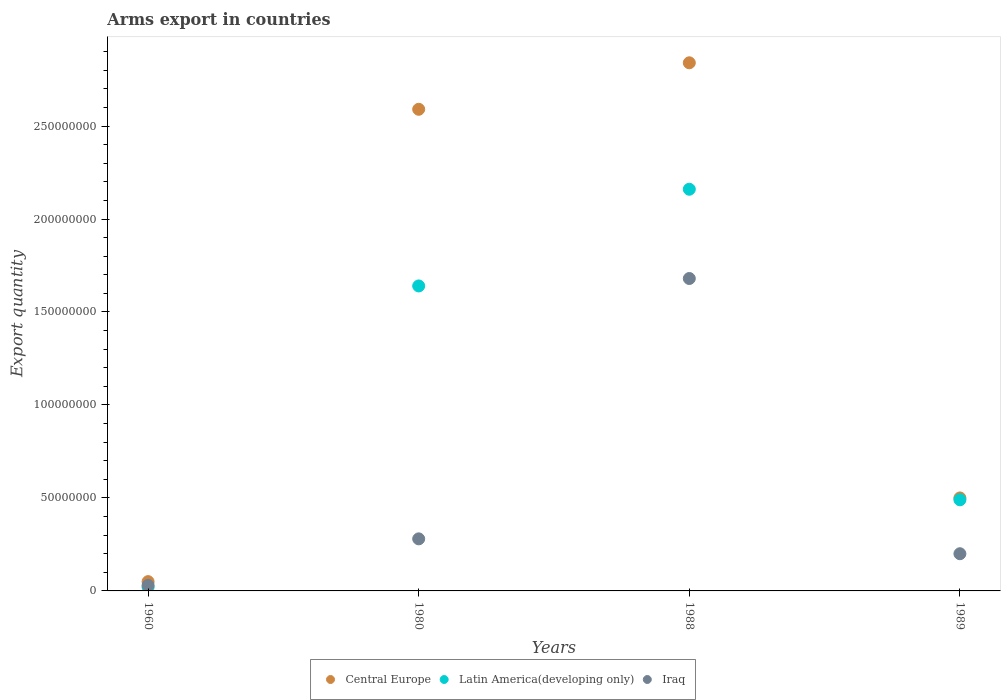Is the number of dotlines equal to the number of legend labels?
Offer a terse response. Yes. What is the total arms export in Iraq in 1989?
Offer a terse response. 2.00e+07. Across all years, what is the maximum total arms export in Central Europe?
Provide a short and direct response. 2.84e+08. In which year was the total arms export in Central Europe maximum?
Keep it short and to the point. 1988. In which year was the total arms export in Central Europe minimum?
Your response must be concise. 1960. What is the total total arms export in Central Europe in the graph?
Offer a terse response. 5.98e+08. What is the difference between the total arms export in Central Europe in 1960 and that in 1989?
Keep it short and to the point. -4.50e+07. What is the difference between the total arms export in Latin America(developing only) in 1988 and the total arms export in Central Europe in 1989?
Keep it short and to the point. 1.66e+08. What is the average total arms export in Latin America(developing only) per year?
Give a very brief answer. 1.08e+08. In the year 1960, what is the difference between the total arms export in Latin America(developing only) and total arms export in Iraq?
Provide a short and direct response. -1.00e+06. In how many years, is the total arms export in Central Europe greater than 90000000?
Make the answer very short. 2. What is the ratio of the total arms export in Central Europe in 1960 to that in 1980?
Your answer should be very brief. 0.02. What is the difference between the highest and the second highest total arms export in Central Europe?
Provide a short and direct response. 2.50e+07. What is the difference between the highest and the lowest total arms export in Latin America(developing only)?
Offer a terse response. 2.14e+08. Is the total arms export in Central Europe strictly greater than the total arms export in Latin America(developing only) over the years?
Give a very brief answer. Yes. How many dotlines are there?
Give a very brief answer. 3. How many years are there in the graph?
Keep it short and to the point. 4. Are the values on the major ticks of Y-axis written in scientific E-notation?
Offer a very short reply. No. Does the graph contain any zero values?
Your answer should be very brief. No. Does the graph contain grids?
Your answer should be compact. No. How are the legend labels stacked?
Keep it short and to the point. Horizontal. What is the title of the graph?
Your response must be concise. Arms export in countries. What is the label or title of the X-axis?
Offer a terse response. Years. What is the label or title of the Y-axis?
Keep it short and to the point. Export quantity. What is the Export quantity in Central Europe in 1960?
Give a very brief answer. 5.00e+06. What is the Export quantity of Latin America(developing only) in 1960?
Offer a terse response. 2.00e+06. What is the Export quantity of Iraq in 1960?
Keep it short and to the point. 3.00e+06. What is the Export quantity of Central Europe in 1980?
Make the answer very short. 2.59e+08. What is the Export quantity in Latin America(developing only) in 1980?
Ensure brevity in your answer.  1.64e+08. What is the Export quantity of Iraq in 1980?
Provide a short and direct response. 2.80e+07. What is the Export quantity of Central Europe in 1988?
Your response must be concise. 2.84e+08. What is the Export quantity of Latin America(developing only) in 1988?
Keep it short and to the point. 2.16e+08. What is the Export quantity of Iraq in 1988?
Provide a succinct answer. 1.68e+08. What is the Export quantity of Central Europe in 1989?
Keep it short and to the point. 5.00e+07. What is the Export quantity of Latin America(developing only) in 1989?
Your answer should be very brief. 4.90e+07. Across all years, what is the maximum Export quantity of Central Europe?
Offer a very short reply. 2.84e+08. Across all years, what is the maximum Export quantity in Latin America(developing only)?
Ensure brevity in your answer.  2.16e+08. Across all years, what is the maximum Export quantity of Iraq?
Give a very brief answer. 1.68e+08. Across all years, what is the minimum Export quantity of Central Europe?
Your answer should be compact. 5.00e+06. What is the total Export quantity in Central Europe in the graph?
Offer a terse response. 5.98e+08. What is the total Export quantity of Latin America(developing only) in the graph?
Your response must be concise. 4.31e+08. What is the total Export quantity in Iraq in the graph?
Give a very brief answer. 2.19e+08. What is the difference between the Export quantity of Central Europe in 1960 and that in 1980?
Make the answer very short. -2.54e+08. What is the difference between the Export quantity of Latin America(developing only) in 1960 and that in 1980?
Keep it short and to the point. -1.62e+08. What is the difference between the Export quantity in Iraq in 1960 and that in 1980?
Make the answer very short. -2.50e+07. What is the difference between the Export quantity in Central Europe in 1960 and that in 1988?
Your response must be concise. -2.79e+08. What is the difference between the Export quantity in Latin America(developing only) in 1960 and that in 1988?
Ensure brevity in your answer.  -2.14e+08. What is the difference between the Export quantity of Iraq in 1960 and that in 1988?
Offer a very short reply. -1.65e+08. What is the difference between the Export quantity in Central Europe in 1960 and that in 1989?
Keep it short and to the point. -4.50e+07. What is the difference between the Export quantity in Latin America(developing only) in 1960 and that in 1989?
Offer a terse response. -4.70e+07. What is the difference between the Export quantity in Iraq in 1960 and that in 1989?
Offer a terse response. -1.70e+07. What is the difference between the Export quantity of Central Europe in 1980 and that in 1988?
Your answer should be compact. -2.50e+07. What is the difference between the Export quantity in Latin America(developing only) in 1980 and that in 1988?
Offer a terse response. -5.20e+07. What is the difference between the Export quantity in Iraq in 1980 and that in 1988?
Give a very brief answer. -1.40e+08. What is the difference between the Export quantity of Central Europe in 1980 and that in 1989?
Keep it short and to the point. 2.09e+08. What is the difference between the Export quantity in Latin America(developing only) in 1980 and that in 1989?
Your answer should be very brief. 1.15e+08. What is the difference between the Export quantity in Central Europe in 1988 and that in 1989?
Provide a short and direct response. 2.34e+08. What is the difference between the Export quantity of Latin America(developing only) in 1988 and that in 1989?
Provide a succinct answer. 1.67e+08. What is the difference between the Export quantity in Iraq in 1988 and that in 1989?
Your response must be concise. 1.48e+08. What is the difference between the Export quantity in Central Europe in 1960 and the Export quantity in Latin America(developing only) in 1980?
Keep it short and to the point. -1.59e+08. What is the difference between the Export quantity in Central Europe in 1960 and the Export quantity in Iraq in 1980?
Provide a short and direct response. -2.30e+07. What is the difference between the Export quantity in Latin America(developing only) in 1960 and the Export quantity in Iraq in 1980?
Your answer should be compact. -2.60e+07. What is the difference between the Export quantity of Central Europe in 1960 and the Export quantity of Latin America(developing only) in 1988?
Your response must be concise. -2.11e+08. What is the difference between the Export quantity in Central Europe in 1960 and the Export quantity in Iraq in 1988?
Provide a succinct answer. -1.63e+08. What is the difference between the Export quantity in Latin America(developing only) in 1960 and the Export quantity in Iraq in 1988?
Keep it short and to the point. -1.66e+08. What is the difference between the Export quantity in Central Europe in 1960 and the Export quantity in Latin America(developing only) in 1989?
Keep it short and to the point. -4.40e+07. What is the difference between the Export quantity of Central Europe in 1960 and the Export quantity of Iraq in 1989?
Keep it short and to the point. -1.50e+07. What is the difference between the Export quantity of Latin America(developing only) in 1960 and the Export quantity of Iraq in 1989?
Provide a succinct answer. -1.80e+07. What is the difference between the Export quantity in Central Europe in 1980 and the Export quantity in Latin America(developing only) in 1988?
Your answer should be very brief. 4.30e+07. What is the difference between the Export quantity in Central Europe in 1980 and the Export quantity in Iraq in 1988?
Your response must be concise. 9.10e+07. What is the difference between the Export quantity of Central Europe in 1980 and the Export quantity of Latin America(developing only) in 1989?
Make the answer very short. 2.10e+08. What is the difference between the Export quantity in Central Europe in 1980 and the Export quantity in Iraq in 1989?
Offer a terse response. 2.39e+08. What is the difference between the Export quantity in Latin America(developing only) in 1980 and the Export quantity in Iraq in 1989?
Offer a very short reply. 1.44e+08. What is the difference between the Export quantity in Central Europe in 1988 and the Export quantity in Latin America(developing only) in 1989?
Your response must be concise. 2.35e+08. What is the difference between the Export quantity of Central Europe in 1988 and the Export quantity of Iraq in 1989?
Give a very brief answer. 2.64e+08. What is the difference between the Export quantity of Latin America(developing only) in 1988 and the Export quantity of Iraq in 1989?
Offer a terse response. 1.96e+08. What is the average Export quantity of Central Europe per year?
Your answer should be compact. 1.50e+08. What is the average Export quantity in Latin America(developing only) per year?
Make the answer very short. 1.08e+08. What is the average Export quantity in Iraq per year?
Ensure brevity in your answer.  5.48e+07. In the year 1960, what is the difference between the Export quantity in Central Europe and Export quantity in Iraq?
Your answer should be very brief. 2.00e+06. In the year 1960, what is the difference between the Export quantity in Latin America(developing only) and Export quantity in Iraq?
Offer a very short reply. -1.00e+06. In the year 1980, what is the difference between the Export quantity of Central Europe and Export quantity of Latin America(developing only)?
Provide a succinct answer. 9.50e+07. In the year 1980, what is the difference between the Export quantity of Central Europe and Export quantity of Iraq?
Provide a succinct answer. 2.31e+08. In the year 1980, what is the difference between the Export quantity in Latin America(developing only) and Export quantity in Iraq?
Your answer should be very brief. 1.36e+08. In the year 1988, what is the difference between the Export quantity of Central Europe and Export quantity of Latin America(developing only)?
Your answer should be compact. 6.80e+07. In the year 1988, what is the difference between the Export quantity of Central Europe and Export quantity of Iraq?
Keep it short and to the point. 1.16e+08. In the year 1988, what is the difference between the Export quantity of Latin America(developing only) and Export quantity of Iraq?
Provide a short and direct response. 4.80e+07. In the year 1989, what is the difference between the Export quantity in Central Europe and Export quantity in Latin America(developing only)?
Make the answer very short. 1.00e+06. In the year 1989, what is the difference between the Export quantity of Central Europe and Export quantity of Iraq?
Offer a terse response. 3.00e+07. In the year 1989, what is the difference between the Export quantity of Latin America(developing only) and Export quantity of Iraq?
Your response must be concise. 2.90e+07. What is the ratio of the Export quantity in Central Europe in 1960 to that in 1980?
Ensure brevity in your answer.  0.02. What is the ratio of the Export quantity in Latin America(developing only) in 1960 to that in 1980?
Ensure brevity in your answer.  0.01. What is the ratio of the Export quantity in Iraq in 1960 to that in 1980?
Offer a very short reply. 0.11. What is the ratio of the Export quantity in Central Europe in 1960 to that in 1988?
Your answer should be very brief. 0.02. What is the ratio of the Export quantity in Latin America(developing only) in 1960 to that in 1988?
Your answer should be compact. 0.01. What is the ratio of the Export quantity of Iraq in 1960 to that in 1988?
Your answer should be compact. 0.02. What is the ratio of the Export quantity of Central Europe in 1960 to that in 1989?
Offer a very short reply. 0.1. What is the ratio of the Export quantity of Latin America(developing only) in 1960 to that in 1989?
Provide a succinct answer. 0.04. What is the ratio of the Export quantity in Iraq in 1960 to that in 1989?
Provide a short and direct response. 0.15. What is the ratio of the Export quantity in Central Europe in 1980 to that in 1988?
Keep it short and to the point. 0.91. What is the ratio of the Export quantity of Latin America(developing only) in 1980 to that in 1988?
Your response must be concise. 0.76. What is the ratio of the Export quantity in Iraq in 1980 to that in 1988?
Provide a succinct answer. 0.17. What is the ratio of the Export quantity in Central Europe in 1980 to that in 1989?
Your response must be concise. 5.18. What is the ratio of the Export quantity of Latin America(developing only) in 1980 to that in 1989?
Keep it short and to the point. 3.35. What is the ratio of the Export quantity of Central Europe in 1988 to that in 1989?
Keep it short and to the point. 5.68. What is the ratio of the Export quantity in Latin America(developing only) in 1988 to that in 1989?
Provide a short and direct response. 4.41. What is the ratio of the Export quantity of Iraq in 1988 to that in 1989?
Keep it short and to the point. 8.4. What is the difference between the highest and the second highest Export quantity of Central Europe?
Make the answer very short. 2.50e+07. What is the difference between the highest and the second highest Export quantity of Latin America(developing only)?
Ensure brevity in your answer.  5.20e+07. What is the difference between the highest and the second highest Export quantity of Iraq?
Provide a short and direct response. 1.40e+08. What is the difference between the highest and the lowest Export quantity of Central Europe?
Ensure brevity in your answer.  2.79e+08. What is the difference between the highest and the lowest Export quantity of Latin America(developing only)?
Your response must be concise. 2.14e+08. What is the difference between the highest and the lowest Export quantity of Iraq?
Offer a terse response. 1.65e+08. 